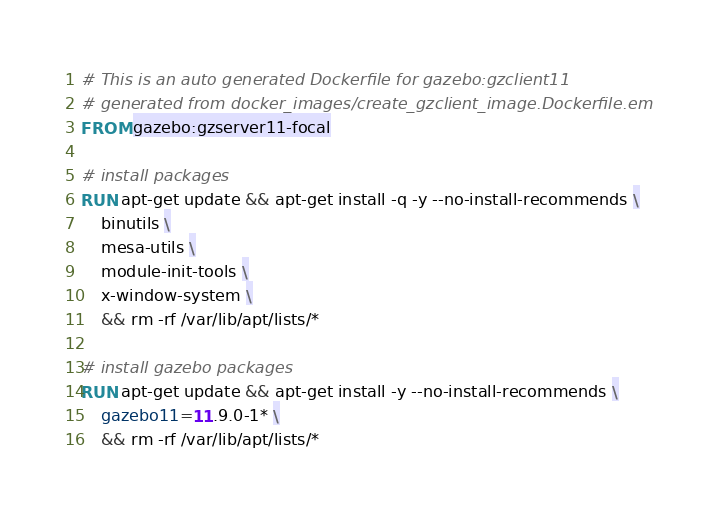Convert code to text. <code><loc_0><loc_0><loc_500><loc_500><_Dockerfile_># This is an auto generated Dockerfile for gazebo:gzclient11
# generated from docker_images/create_gzclient_image.Dockerfile.em
FROM gazebo:gzserver11-focal

# install packages
RUN apt-get update && apt-get install -q -y --no-install-recommends \
    binutils \
    mesa-utils \
    module-init-tools \
    x-window-system \
    && rm -rf /var/lib/apt/lists/*

# install gazebo packages
RUN apt-get update && apt-get install -y --no-install-recommends \
    gazebo11=11.9.0-1* \
    && rm -rf /var/lib/apt/lists/*

</code> 